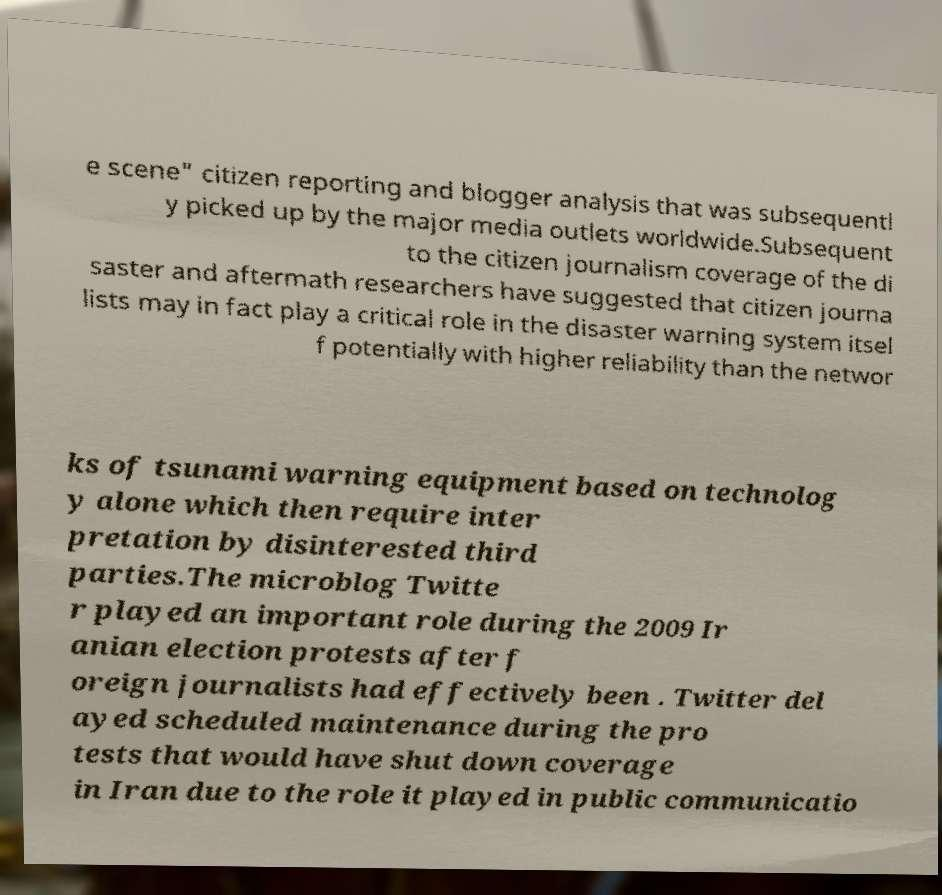Can you read and provide the text displayed in the image?This photo seems to have some interesting text. Can you extract and type it out for me? e scene" citizen reporting and blogger analysis that was subsequentl y picked up by the major media outlets worldwide.Subsequent to the citizen journalism coverage of the di saster and aftermath researchers have suggested that citizen journa lists may in fact play a critical role in the disaster warning system itsel f potentially with higher reliability than the networ ks of tsunami warning equipment based on technolog y alone which then require inter pretation by disinterested third parties.The microblog Twitte r played an important role during the 2009 Ir anian election protests after f oreign journalists had effectively been . Twitter del ayed scheduled maintenance during the pro tests that would have shut down coverage in Iran due to the role it played in public communicatio 